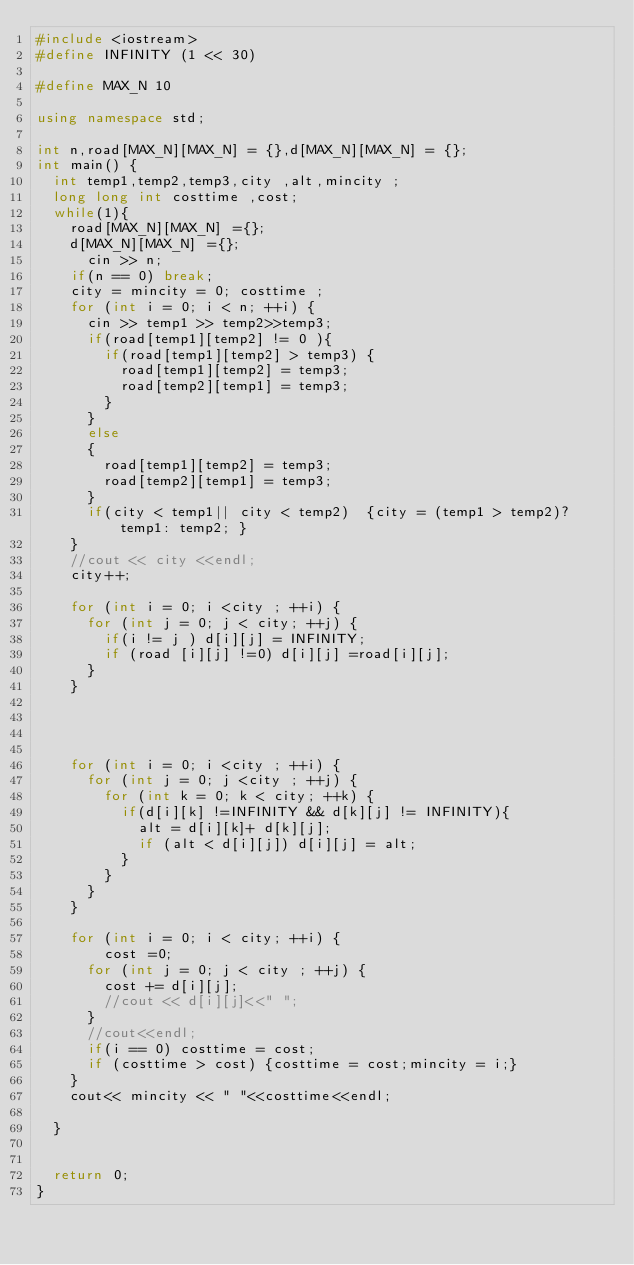<code> <loc_0><loc_0><loc_500><loc_500><_C++_>#include <iostream>
#define INFINITY (1 << 30)

#define MAX_N 10

using namespace std;

int n,road[MAX_N][MAX_N] = {},d[MAX_N][MAX_N] = {};
int main() {
  int temp1,temp2,temp3,city ,alt,mincity ;
  long long int costtime ,cost;
  while(1){
    road[MAX_N][MAX_N] ={};
    d[MAX_N][MAX_N] ={};
      cin >> n;
    if(n == 0) break;
    city = mincity = 0; costtime ;
    for (int i = 0; i < n; ++i) {
      cin >> temp1 >> temp2>>temp3;
      if(road[temp1][temp2] != 0 ){
        if(road[temp1][temp2] > temp3) {
          road[temp1][temp2] = temp3;
          road[temp2][temp1] = temp3;
        }
      }
      else
      {
        road[temp1][temp2] = temp3;
        road[temp2][temp1] = temp3;
      }
      if(city < temp1|| city < temp2)  {city = (temp1 > temp2)?  temp1: temp2; }
    }
    //cout << city <<endl;
    city++;

    for (int i = 0; i <city ; ++i) {
      for (int j = 0; j < city; ++j) {
        if(i != j ) d[i][j] = INFINITY;
        if (road [i][j] !=0) d[i][j] =road[i][j];
      }
    }




    for (int i = 0; i <city ; ++i) {
      for (int j = 0; j <city ; ++j) {
        for (int k = 0; k < city; ++k) {
          if(d[i][k] !=INFINITY && d[k][j] != INFINITY){
            alt = d[i][k]+ d[k][j];
            if (alt < d[i][j]) d[i][j] = alt;
          }
        }
      }
    }

    for (int i = 0; i < city; ++i) {
        cost =0;
      for (int j = 0; j < city ; ++j) {
        cost += d[i][j];
        //cout << d[i][j]<<" ";
      }
      //cout<<endl;
      if(i == 0) costtime = cost;
      if (costtime > cost) {costtime = cost;mincity = i;}
    }
    cout<< mincity << " "<<costtime<<endl;

  }


  return 0;
}</code> 